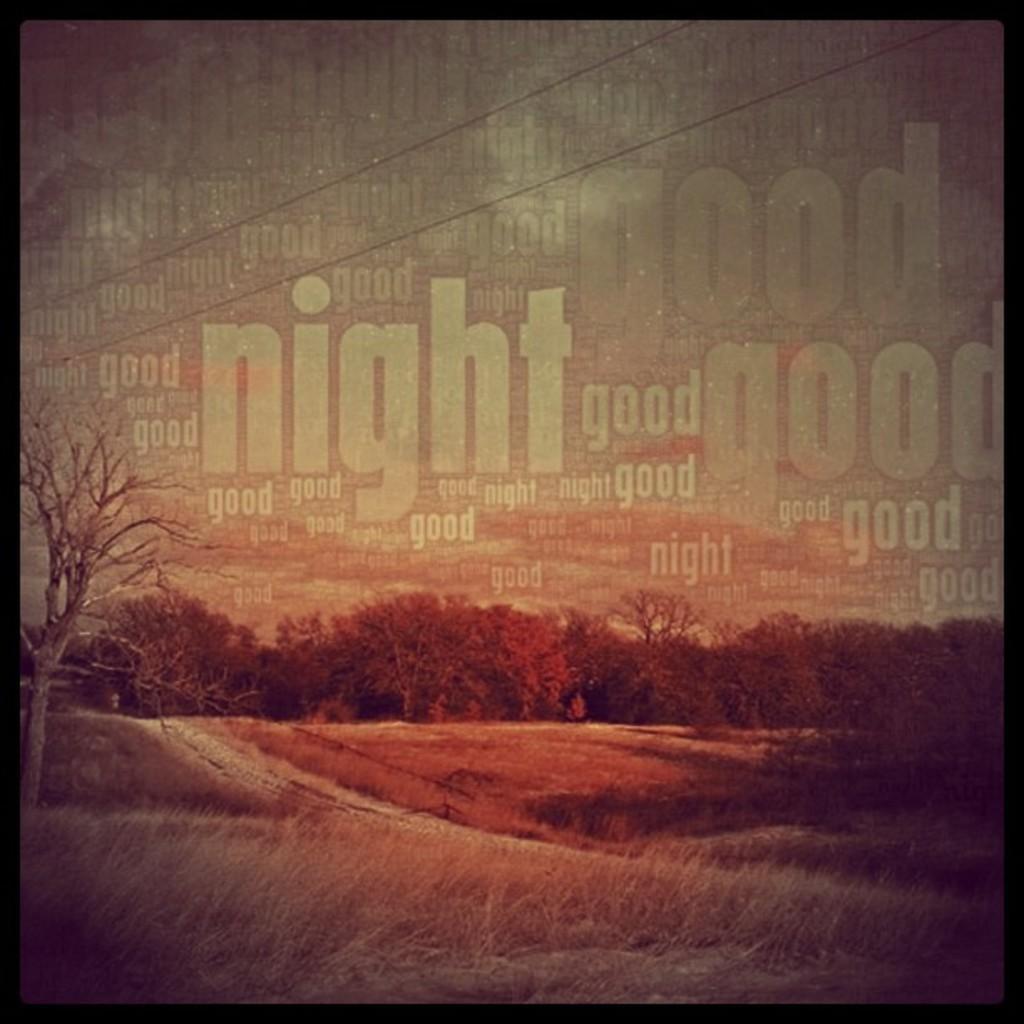Could you give a brief overview of what you see in this image? This is an edited picture. In this image there are trees. At the top there is sky and their wires and there is text. At the bottom there is grass. 